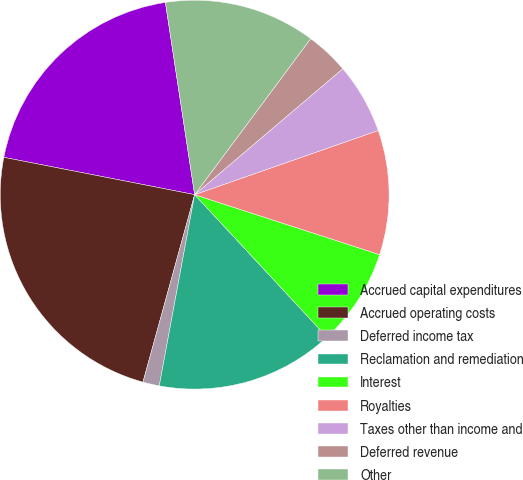<chart> <loc_0><loc_0><loc_500><loc_500><pie_chart><fcel>Accrued capital expenditures<fcel>Accrued operating costs<fcel>Deferred income tax<fcel>Reclamation and remediation<fcel>Interest<fcel>Royalties<fcel>Taxes other than income and<fcel>Deferred revenue<fcel>Other<nl><fcel>19.52%<fcel>23.79%<fcel>1.37%<fcel>14.82%<fcel>8.1%<fcel>10.34%<fcel>5.86%<fcel>3.61%<fcel>12.58%<nl></chart> 